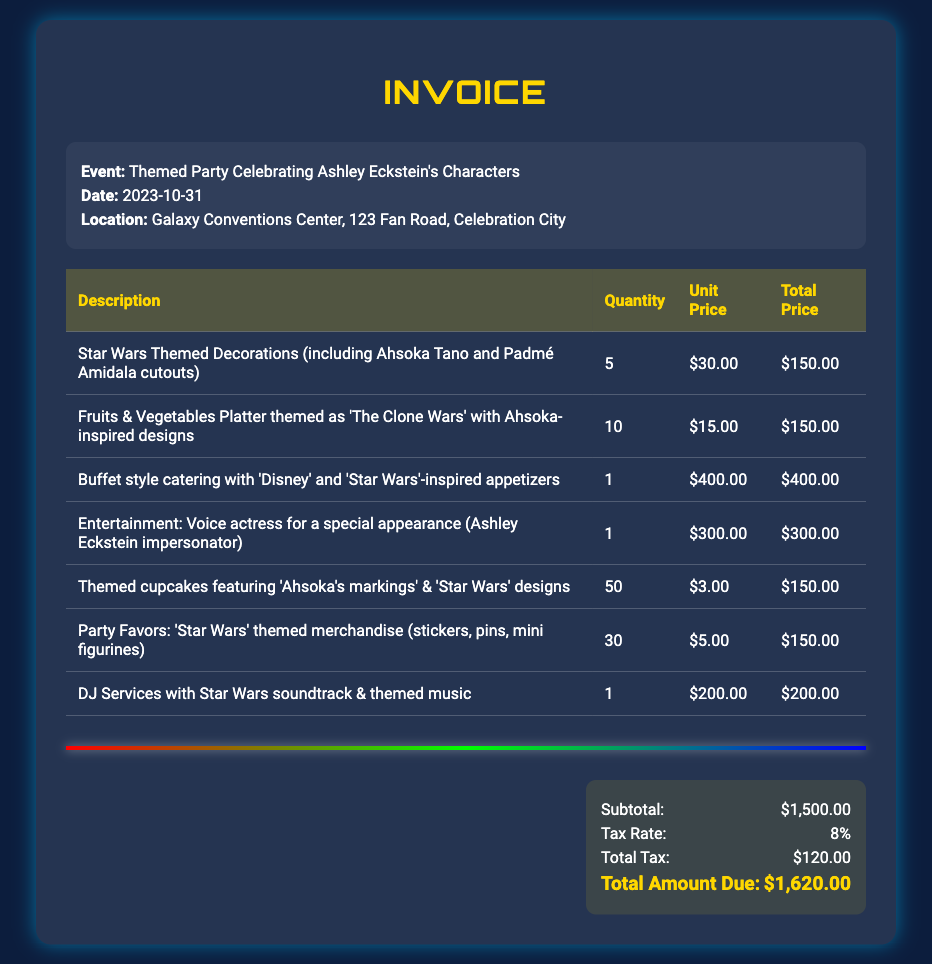What is the date of the event? The date of the event is listed in the document as '2023-10-31'.
Answer: 2023-10-31 What is the total amount due? The total amount due is specified in the 'Total Amount Due' section of the document as '$1,620.00'.
Answer: $1,620.00 How many themed cupcakes are included? The document states there are '50' themed cupcakes listed under the food section.
Answer: 50 What is the unit price of the buffet catering? The unit price for the buffet style catering is shown as '$400.00' in the invoice.
Answer: $400.00 What type of entertainment is being provided? The entertainment section mentions a 'Voice actress for a special appearance (Ashley Eckstein impersonator)'.
Answer: Voice actress for a special appearance (Ashley Eckstein impersonator) How many party favors are there? The quantity of party favors listed in the document is '30'.
Answer: 30 What is the tax rate applied? The tax rate mentioned in the document is '8%'.
Answer: 8% What is included in the decorations? The document notes 'Star Wars Themed Decorations (including Ahsoka Tano and Padmé Amidala cutouts)'.
Answer: Star Wars Themed Decorations (including Ahsoka Tano and Padmé Amidala cutouts) What is the subtotal before tax? The subtotal before tax is provided in the document as '$1,500.00'.
Answer: $1,500.00 